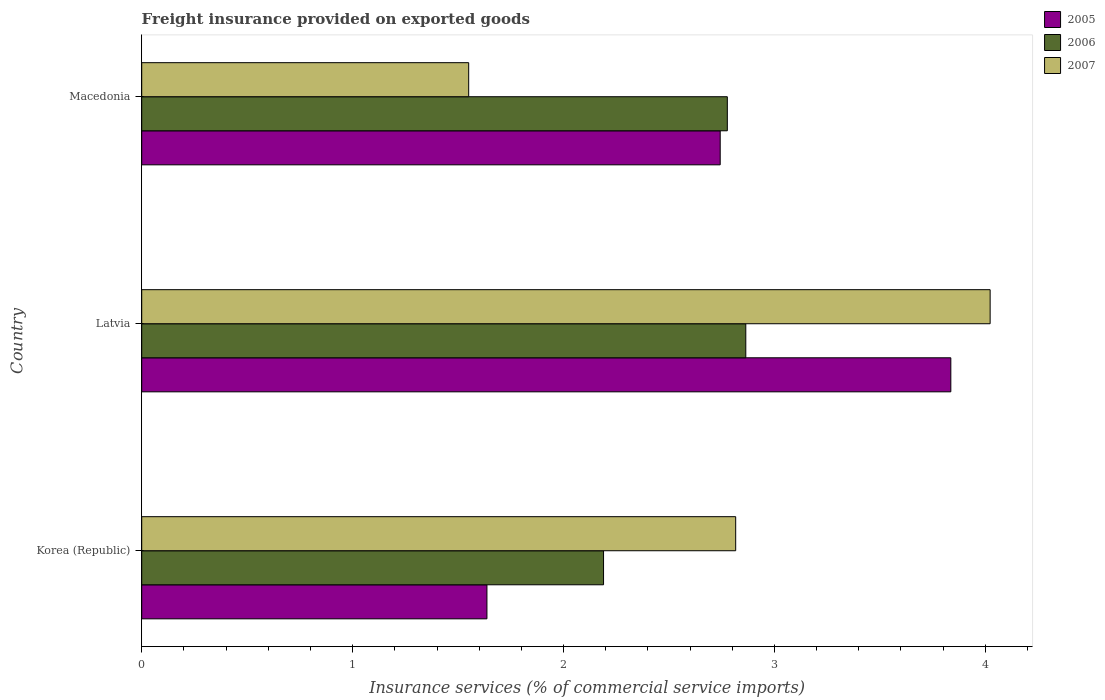How many groups of bars are there?
Your answer should be very brief. 3. Are the number of bars per tick equal to the number of legend labels?
Offer a terse response. Yes. How many bars are there on the 1st tick from the bottom?
Your response must be concise. 3. What is the label of the 1st group of bars from the top?
Ensure brevity in your answer.  Macedonia. What is the freight insurance provided on exported goods in 2005 in Macedonia?
Offer a very short reply. 2.74. Across all countries, what is the maximum freight insurance provided on exported goods in 2007?
Provide a succinct answer. 4.02. Across all countries, what is the minimum freight insurance provided on exported goods in 2006?
Your answer should be compact. 2.19. In which country was the freight insurance provided on exported goods in 2005 maximum?
Your response must be concise. Latvia. What is the total freight insurance provided on exported goods in 2007 in the graph?
Ensure brevity in your answer.  8.39. What is the difference between the freight insurance provided on exported goods in 2005 in Korea (Republic) and that in Latvia?
Your response must be concise. -2.2. What is the difference between the freight insurance provided on exported goods in 2006 in Macedonia and the freight insurance provided on exported goods in 2005 in Latvia?
Your response must be concise. -1.06. What is the average freight insurance provided on exported goods in 2005 per country?
Keep it short and to the point. 2.74. What is the difference between the freight insurance provided on exported goods in 2005 and freight insurance provided on exported goods in 2006 in Korea (Republic)?
Offer a terse response. -0.55. What is the ratio of the freight insurance provided on exported goods in 2005 in Korea (Republic) to that in Latvia?
Provide a short and direct response. 0.43. Is the freight insurance provided on exported goods in 2007 in Latvia less than that in Macedonia?
Keep it short and to the point. No. What is the difference between the highest and the second highest freight insurance provided on exported goods in 2007?
Keep it short and to the point. 1.21. What is the difference between the highest and the lowest freight insurance provided on exported goods in 2007?
Provide a succinct answer. 2.47. In how many countries, is the freight insurance provided on exported goods in 2007 greater than the average freight insurance provided on exported goods in 2007 taken over all countries?
Your response must be concise. 2. What does the 3rd bar from the top in Macedonia represents?
Make the answer very short. 2005. What does the 1st bar from the bottom in Korea (Republic) represents?
Your answer should be very brief. 2005. How many bars are there?
Your response must be concise. 9. Are all the bars in the graph horizontal?
Keep it short and to the point. Yes. Are the values on the major ticks of X-axis written in scientific E-notation?
Provide a short and direct response. No. Where does the legend appear in the graph?
Make the answer very short. Top right. What is the title of the graph?
Your response must be concise. Freight insurance provided on exported goods. Does "1978" appear as one of the legend labels in the graph?
Provide a short and direct response. No. What is the label or title of the X-axis?
Provide a short and direct response. Insurance services (% of commercial service imports). What is the label or title of the Y-axis?
Your answer should be compact. Country. What is the Insurance services (% of commercial service imports) of 2005 in Korea (Republic)?
Provide a succinct answer. 1.64. What is the Insurance services (% of commercial service imports) of 2006 in Korea (Republic)?
Ensure brevity in your answer.  2.19. What is the Insurance services (% of commercial service imports) in 2007 in Korea (Republic)?
Make the answer very short. 2.82. What is the Insurance services (% of commercial service imports) in 2005 in Latvia?
Your answer should be compact. 3.84. What is the Insurance services (% of commercial service imports) of 2006 in Latvia?
Provide a succinct answer. 2.86. What is the Insurance services (% of commercial service imports) of 2007 in Latvia?
Make the answer very short. 4.02. What is the Insurance services (% of commercial service imports) of 2005 in Macedonia?
Provide a succinct answer. 2.74. What is the Insurance services (% of commercial service imports) of 2006 in Macedonia?
Offer a terse response. 2.78. What is the Insurance services (% of commercial service imports) of 2007 in Macedonia?
Provide a succinct answer. 1.55. Across all countries, what is the maximum Insurance services (% of commercial service imports) of 2005?
Your answer should be compact. 3.84. Across all countries, what is the maximum Insurance services (% of commercial service imports) in 2006?
Ensure brevity in your answer.  2.86. Across all countries, what is the maximum Insurance services (% of commercial service imports) of 2007?
Offer a terse response. 4.02. Across all countries, what is the minimum Insurance services (% of commercial service imports) of 2005?
Your answer should be very brief. 1.64. Across all countries, what is the minimum Insurance services (% of commercial service imports) in 2006?
Ensure brevity in your answer.  2.19. Across all countries, what is the minimum Insurance services (% of commercial service imports) in 2007?
Ensure brevity in your answer.  1.55. What is the total Insurance services (% of commercial service imports) of 2005 in the graph?
Provide a short and direct response. 8.22. What is the total Insurance services (% of commercial service imports) of 2006 in the graph?
Your answer should be compact. 7.83. What is the total Insurance services (% of commercial service imports) of 2007 in the graph?
Make the answer very short. 8.39. What is the difference between the Insurance services (% of commercial service imports) of 2005 in Korea (Republic) and that in Latvia?
Your response must be concise. -2.2. What is the difference between the Insurance services (% of commercial service imports) in 2006 in Korea (Republic) and that in Latvia?
Your response must be concise. -0.67. What is the difference between the Insurance services (% of commercial service imports) in 2007 in Korea (Republic) and that in Latvia?
Your answer should be compact. -1.21. What is the difference between the Insurance services (% of commercial service imports) in 2005 in Korea (Republic) and that in Macedonia?
Your response must be concise. -1.11. What is the difference between the Insurance services (% of commercial service imports) in 2006 in Korea (Republic) and that in Macedonia?
Give a very brief answer. -0.59. What is the difference between the Insurance services (% of commercial service imports) in 2007 in Korea (Republic) and that in Macedonia?
Give a very brief answer. 1.27. What is the difference between the Insurance services (% of commercial service imports) in 2005 in Latvia and that in Macedonia?
Your response must be concise. 1.09. What is the difference between the Insurance services (% of commercial service imports) of 2006 in Latvia and that in Macedonia?
Ensure brevity in your answer.  0.09. What is the difference between the Insurance services (% of commercial service imports) of 2007 in Latvia and that in Macedonia?
Your answer should be compact. 2.47. What is the difference between the Insurance services (% of commercial service imports) of 2005 in Korea (Republic) and the Insurance services (% of commercial service imports) of 2006 in Latvia?
Offer a terse response. -1.23. What is the difference between the Insurance services (% of commercial service imports) in 2005 in Korea (Republic) and the Insurance services (% of commercial service imports) in 2007 in Latvia?
Offer a terse response. -2.39. What is the difference between the Insurance services (% of commercial service imports) of 2006 in Korea (Republic) and the Insurance services (% of commercial service imports) of 2007 in Latvia?
Keep it short and to the point. -1.83. What is the difference between the Insurance services (% of commercial service imports) of 2005 in Korea (Republic) and the Insurance services (% of commercial service imports) of 2006 in Macedonia?
Offer a terse response. -1.14. What is the difference between the Insurance services (% of commercial service imports) in 2005 in Korea (Republic) and the Insurance services (% of commercial service imports) in 2007 in Macedonia?
Offer a terse response. 0.09. What is the difference between the Insurance services (% of commercial service imports) in 2006 in Korea (Republic) and the Insurance services (% of commercial service imports) in 2007 in Macedonia?
Your answer should be compact. 0.64. What is the difference between the Insurance services (% of commercial service imports) of 2005 in Latvia and the Insurance services (% of commercial service imports) of 2006 in Macedonia?
Your answer should be compact. 1.06. What is the difference between the Insurance services (% of commercial service imports) in 2005 in Latvia and the Insurance services (% of commercial service imports) in 2007 in Macedonia?
Ensure brevity in your answer.  2.29. What is the difference between the Insurance services (% of commercial service imports) of 2006 in Latvia and the Insurance services (% of commercial service imports) of 2007 in Macedonia?
Make the answer very short. 1.31. What is the average Insurance services (% of commercial service imports) of 2005 per country?
Give a very brief answer. 2.74. What is the average Insurance services (% of commercial service imports) of 2006 per country?
Keep it short and to the point. 2.61. What is the average Insurance services (% of commercial service imports) of 2007 per country?
Give a very brief answer. 2.8. What is the difference between the Insurance services (% of commercial service imports) in 2005 and Insurance services (% of commercial service imports) in 2006 in Korea (Republic)?
Give a very brief answer. -0.55. What is the difference between the Insurance services (% of commercial service imports) of 2005 and Insurance services (% of commercial service imports) of 2007 in Korea (Republic)?
Ensure brevity in your answer.  -1.18. What is the difference between the Insurance services (% of commercial service imports) of 2006 and Insurance services (% of commercial service imports) of 2007 in Korea (Republic)?
Make the answer very short. -0.63. What is the difference between the Insurance services (% of commercial service imports) of 2005 and Insurance services (% of commercial service imports) of 2006 in Latvia?
Give a very brief answer. 0.97. What is the difference between the Insurance services (% of commercial service imports) of 2005 and Insurance services (% of commercial service imports) of 2007 in Latvia?
Provide a succinct answer. -0.19. What is the difference between the Insurance services (% of commercial service imports) of 2006 and Insurance services (% of commercial service imports) of 2007 in Latvia?
Offer a very short reply. -1.16. What is the difference between the Insurance services (% of commercial service imports) of 2005 and Insurance services (% of commercial service imports) of 2006 in Macedonia?
Make the answer very short. -0.03. What is the difference between the Insurance services (% of commercial service imports) of 2005 and Insurance services (% of commercial service imports) of 2007 in Macedonia?
Offer a terse response. 1.19. What is the difference between the Insurance services (% of commercial service imports) in 2006 and Insurance services (% of commercial service imports) in 2007 in Macedonia?
Your answer should be compact. 1.23. What is the ratio of the Insurance services (% of commercial service imports) in 2005 in Korea (Republic) to that in Latvia?
Keep it short and to the point. 0.43. What is the ratio of the Insurance services (% of commercial service imports) in 2006 in Korea (Republic) to that in Latvia?
Give a very brief answer. 0.76. What is the ratio of the Insurance services (% of commercial service imports) of 2007 in Korea (Republic) to that in Latvia?
Your response must be concise. 0.7. What is the ratio of the Insurance services (% of commercial service imports) in 2005 in Korea (Republic) to that in Macedonia?
Your response must be concise. 0.6. What is the ratio of the Insurance services (% of commercial service imports) of 2006 in Korea (Republic) to that in Macedonia?
Your answer should be very brief. 0.79. What is the ratio of the Insurance services (% of commercial service imports) of 2007 in Korea (Republic) to that in Macedonia?
Offer a terse response. 1.82. What is the ratio of the Insurance services (% of commercial service imports) of 2005 in Latvia to that in Macedonia?
Provide a short and direct response. 1.4. What is the ratio of the Insurance services (% of commercial service imports) of 2006 in Latvia to that in Macedonia?
Ensure brevity in your answer.  1.03. What is the ratio of the Insurance services (% of commercial service imports) of 2007 in Latvia to that in Macedonia?
Ensure brevity in your answer.  2.59. What is the difference between the highest and the second highest Insurance services (% of commercial service imports) in 2005?
Your answer should be compact. 1.09. What is the difference between the highest and the second highest Insurance services (% of commercial service imports) in 2006?
Your response must be concise. 0.09. What is the difference between the highest and the second highest Insurance services (% of commercial service imports) in 2007?
Provide a succinct answer. 1.21. What is the difference between the highest and the lowest Insurance services (% of commercial service imports) in 2005?
Offer a very short reply. 2.2. What is the difference between the highest and the lowest Insurance services (% of commercial service imports) in 2006?
Keep it short and to the point. 0.67. What is the difference between the highest and the lowest Insurance services (% of commercial service imports) of 2007?
Give a very brief answer. 2.47. 